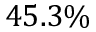Convert formula to latex. <formula><loc_0><loc_0><loc_500><loc_500>4 5 . 3 \%</formula> 